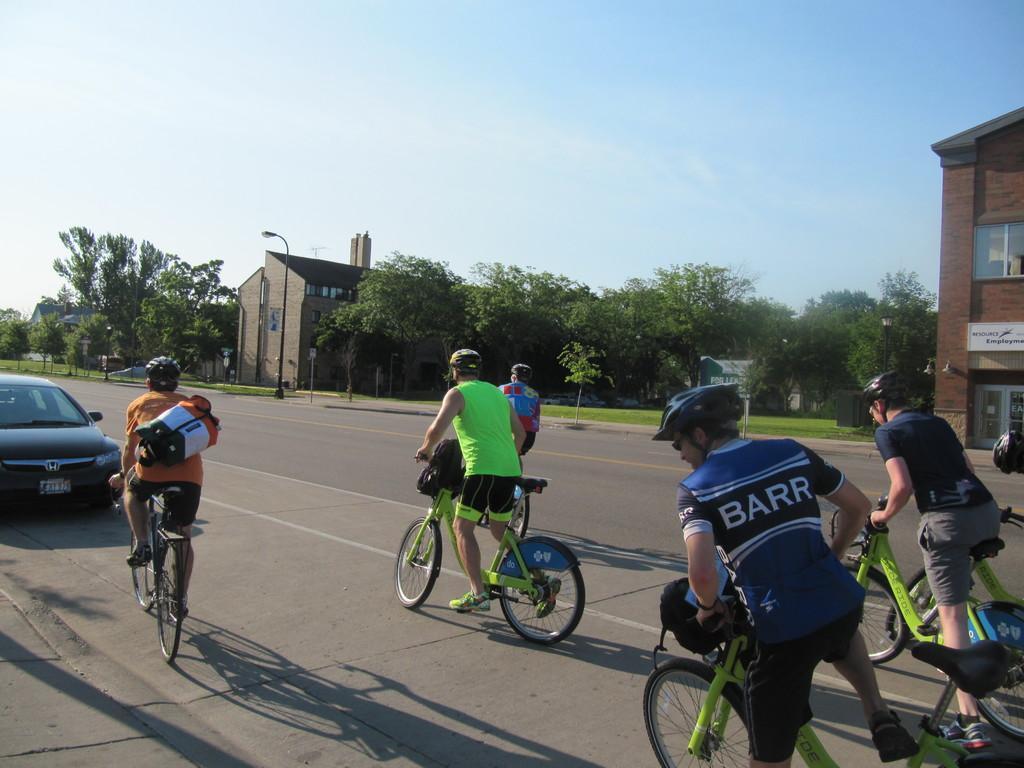Describe this image in one or two sentences. This is a road. And car is on the road. Many riders are riding the cycle. A person wearing orange shirt is having a bag and helmet. On the side of the road there are trees, buildings and above sky is there. 